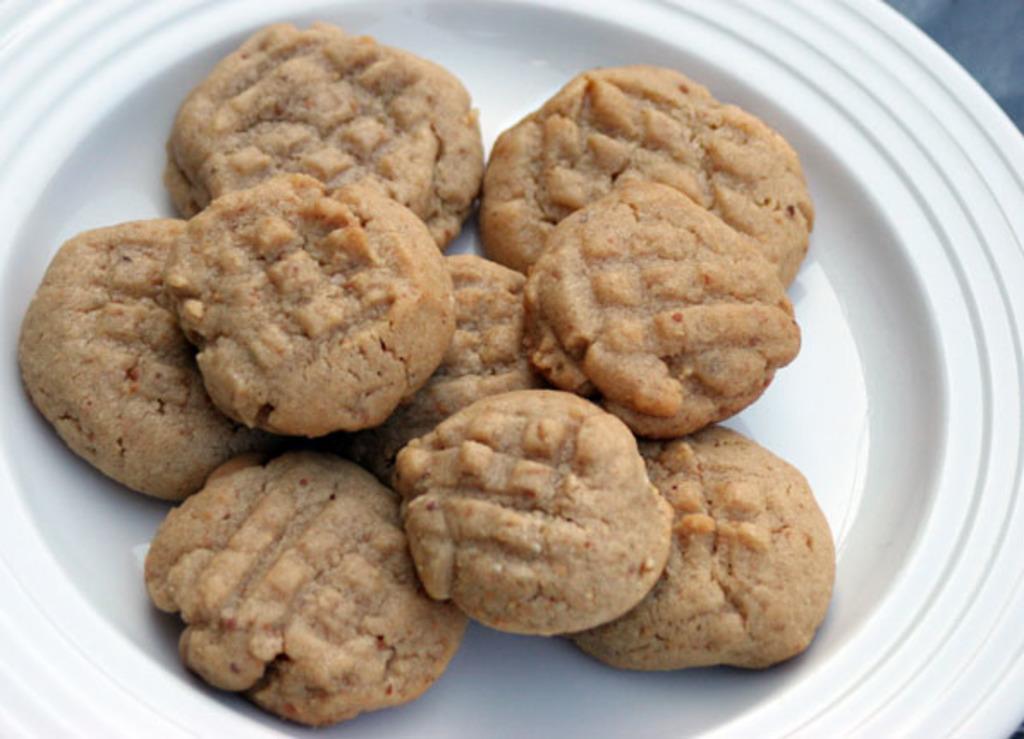Could you give a brief overview of what you see in this image? In this image we can see some cookies in the white color bowl. 